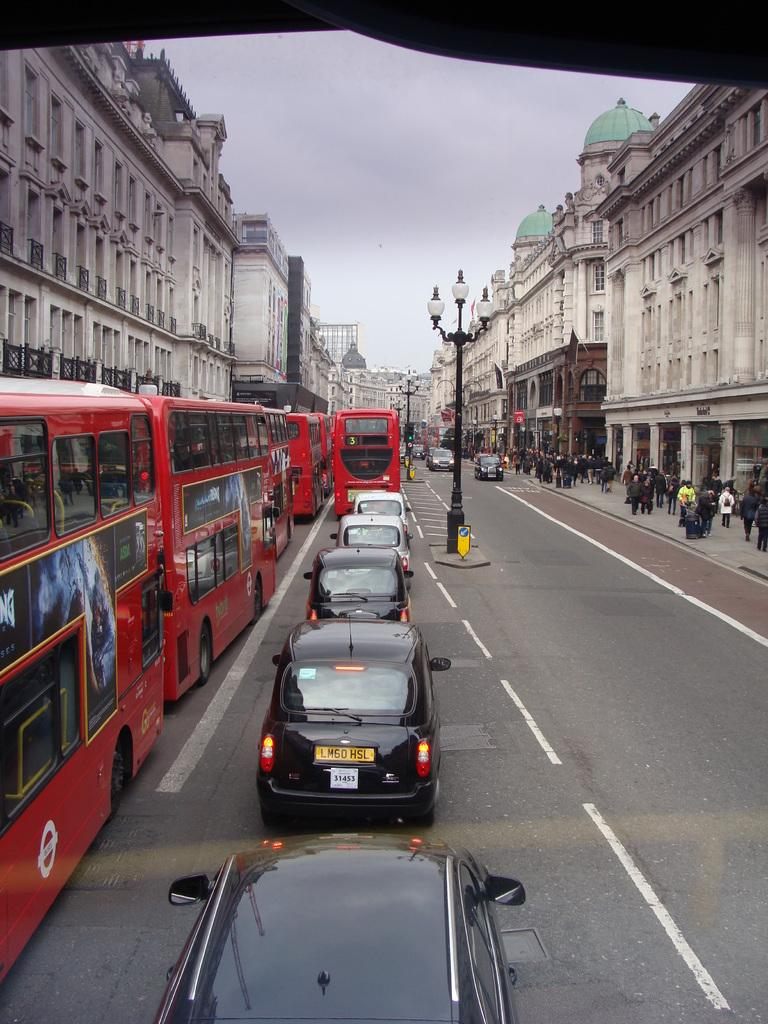What can be seen on the road in the image? There are vehicles on the road in the image. What structures are present alongside the road? There are light poles in the image. What is located on the right side of the image? There are people on the right side of the image. What type of structures can be seen on both sides of the road? There are buildings on both sides of the image. What is visible in the background of the image? The sky is visible in the background of the image. Can you tell me how many dogs are walking on the pipe in the image? There are no dogs or pipes present in the image. What type of shock can be seen affecting the light poles in the image? There is no shock present in the image; the light poles are stationary. 